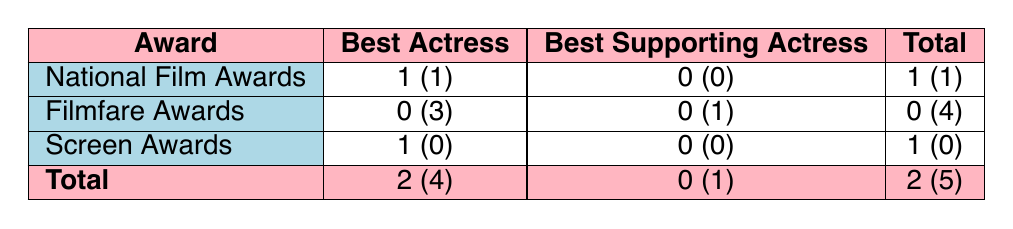What is the total number of awards won by Deepti Naval? The table shows that Deepti Naval has won 1 award in the National Film Awards and 1 in the Screen Awards, which totals to 1 + 1 = 2.
Answer: 2 How many nominations did Deepti Naval receive in the Filmfare Awards? According to the table, Deepti Naval received 3 nominations in the Best Actress category and 1 in the Best Supporting Actress category, which totals to 3 + 1 = 4 nominations in the Filmfare Awards.
Answer: 4 Did Deepti Naval win any Filmfare Awards? The table indicates that Deepti Naval did not win any Filmfare Awards since all entries in this category show zero wins.
Answer: No Which award category had the most nominations for Deepti Naval? The table shows that the Best Actress category had 4 nominations (3 in Filmfare Awards and 1 in National Film Awards), and the Best Supporting Actress category had 1 nomination. Therefore, Best Actress had more nominations than any other category.
Answer: Best Actress What is the difference in the number of wins between the National Film Awards and the Screen Awards? The National Film Awards had 1 win (Best Actress), and the Screen Awards also had 1 win. Therefore, the difference in wins is 1 - 1 = 0.
Answer: 0 How many total nominations did Deepti Naval receive in Best Actress category? The table lists 4 nominations in the Best Actress category (1 from National Film Awards, 3 from Filmfare Awards, and 1 from Screen Awards), thus giving a total of 4 nominations.
Answer: 4 Did Deepti Naval receive a nomination for Best Supporting Actress? The data in the table shows that she received 1 nomination for Best Supporting Actress but did not win any, confirming that she did receive a nomination in that category.
Answer: Yes What is the total number of awards and nominations for each category? The awards are: National Film Awards 1 (1) + Filmfare Awards 0 (4) + Screen Awards 1 (0) = 2+(4) nominations, Best Supporting Actress: 0 (1) nominations giving total nominations of 5. Thus, Total Awards and Nominations = 2 awards and 5 nominations.
Answer: 7 (2 awards and 5 nominations) 